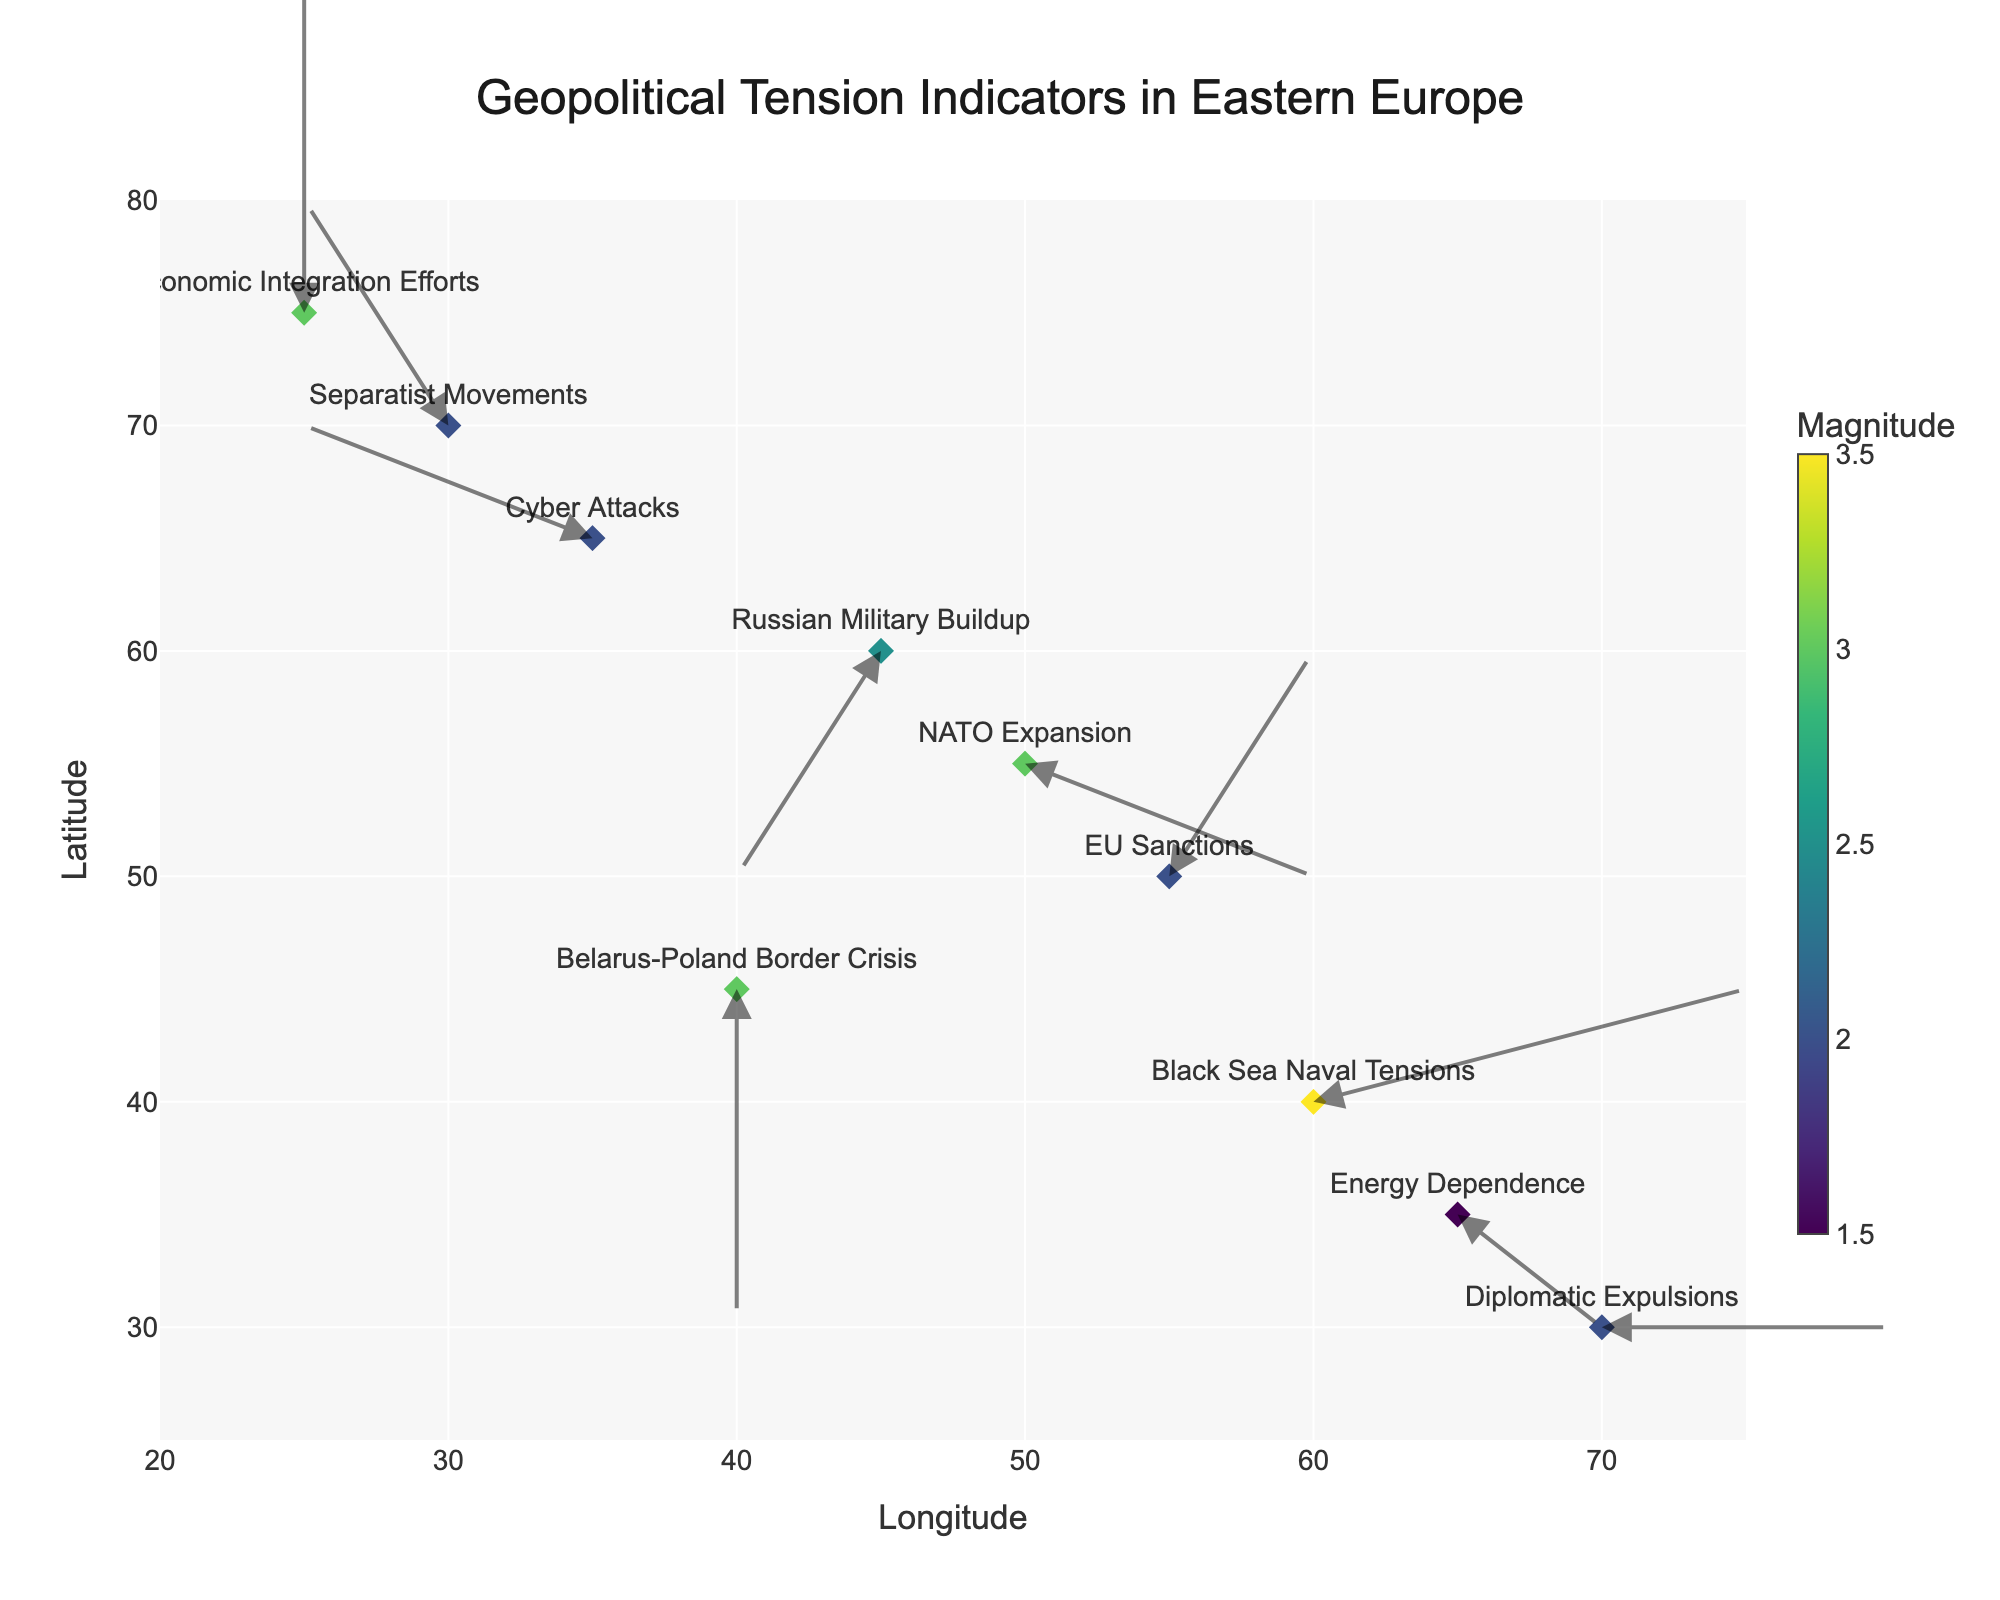What's the title of the quiver plot? The title is located at the top of the figure and usually provides a summary of what the plot is about. The title for this plot is "Geopolitical Tension Indicators in Eastern Europe".
Answer: Geopolitical Tension Indicators in Eastern Europe What do the colors of the markers represent? Colors in the plot often represent a quantitative variable. In this plot, the colors indicate the magnitude of each geopolitical tension indicator.
Answer: Magnitude How many indicators have a negative component in the Y direction? To answer this, look at the direction of each arrow. If the Y component (V) is negative, the arrow will point downward. Several indicators like "NATO Expansion", "Russian Military Buildup", "Energy Dependence", and "Diplomatic Expulsions" have a negative Y component. The count is 4.
Answer: 4 Which indicator has the highest magnitude, and what is its value? The color scale helps to determine the magnitude, with darker colors on the "Viridis" scale indicating higher values. The "Black Sea Naval Tensions" has the darkest color indicating the highest magnitude of 3.5.
Answer: Black Sea Naval Tensions, 3.5 What is the direction of the arrow for "Cyber Attacks"? The direction can be understood by looking at the components (U, V) of the arrow. "Cyber Attacks" has U = -2 and V = 1, indicating the arrow goes left and slightly upward.
Answer: Left and slightly upward Which indicator’s arrow points directly downward, and what is its magnitude? To find the indicator with an arrow pointing directly downward, look for a U component of 0 and a negative V component. "Belarus-Poland Border Crisis" fits this and has a magnitude of 3.
Answer: Belarus-Poland Border Crisis, 3 Which indicators have arrows that point to the right? Indicators pointing to the right have a positive U component. These include "NATO Expansion", "EU Sanctions", "Black Sea Naval Tensions", "Energy Dependence", and "Diplomatic Expulsions".
Answer: NATO Expansion, EU Sanctions, Black Sea Naval Tensions, Energy Dependence, Diplomatic Expulsions Identify the indicator whose arrow points towards the upper left direction and finds its magnitude. Arrows pointing upper left have a negative U component and a positive V component. "Separatist Movements" fits this criteria and has a magnitude of 2.
Answer: Separatist Movements, 2 What is the average latitude (Y-value) of all indicators listed? Sum all Y values: (55+60+50+45+40+65+35+70+30+75) = 525. The number of indicators is 10. Average = 525/10 = 52.5.
Answer: 52.5 Which indicator is found at the highest latitude, and what is its latitude and longitude? Look for the highest Y value. "Economic Integration Efforts" has the highest Y value at 75, and its longitude (X-value) is 25.
Answer: Economic Integration Efforts, Latitude 75, Longitude 25 